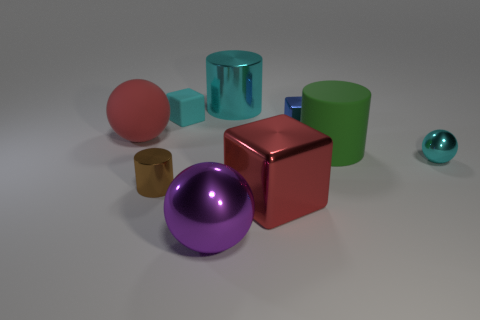What can these objects tell us about the concept of light and shadows in 3D rendering? The composition of these objects with their varying materials and colors provides an excellent study in 3D rendering, showcasing how light interacts with surfaces differently. Metallic objects reflect light strongly, creating bright highlights and clear reflections, while matte surfaces scatter light, producing softer shadows. Transparent objects refract and distort light, highlighting rendering techniques for transparency and refraction. It's a visual representation of how light sources and object materials work together to create a realistic scene.  Could you infer the position of the light source in this scene? The light source appears to be coming from the upper right side of the scene. This is inferred from the direction of the shadows cast by the objects, which extend towards the lower left. Additionally, the reflections and highlights on the metal and glass materials further suggest the light direction, as they are more pronounced on the sides of the objects facing the upper right. 